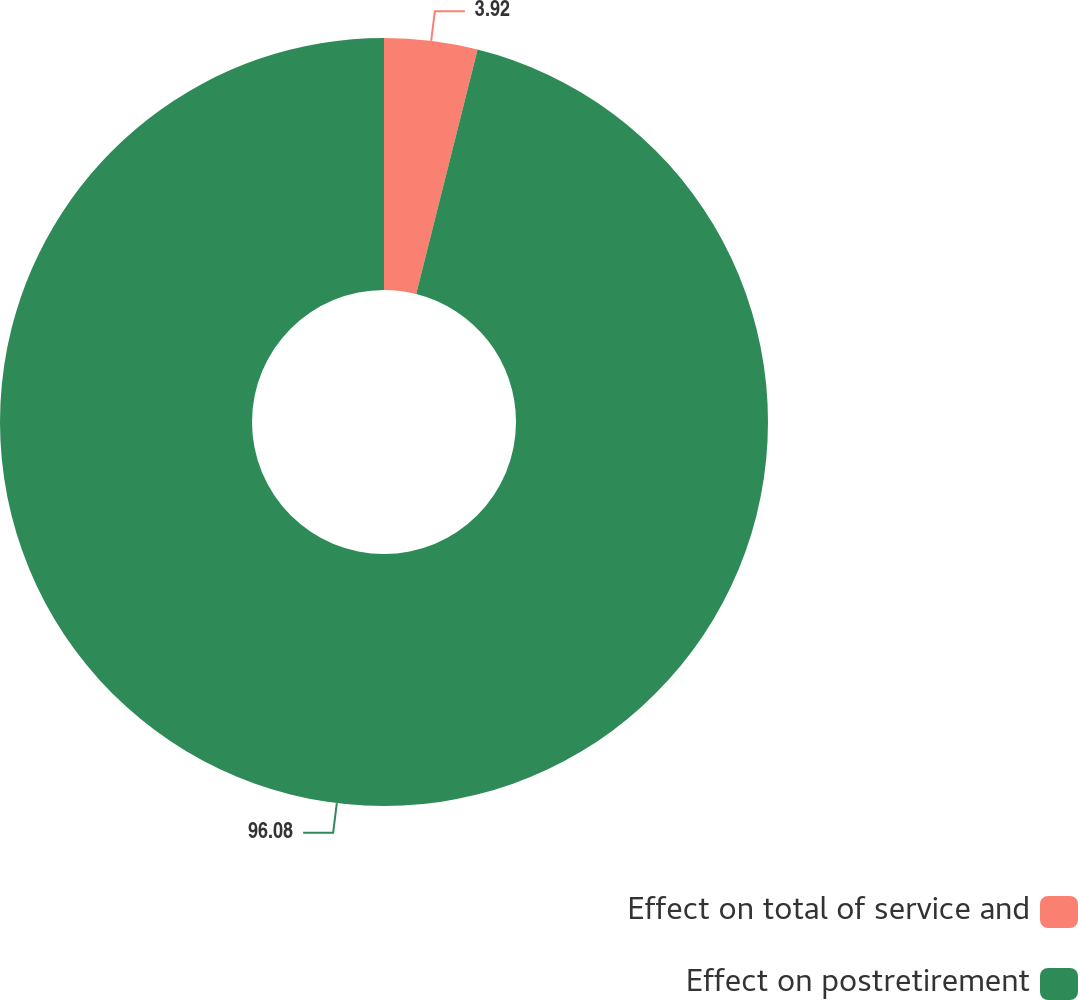<chart> <loc_0><loc_0><loc_500><loc_500><pie_chart><fcel>Effect on total of service and<fcel>Effect on postretirement<nl><fcel>3.92%<fcel>96.08%<nl></chart> 